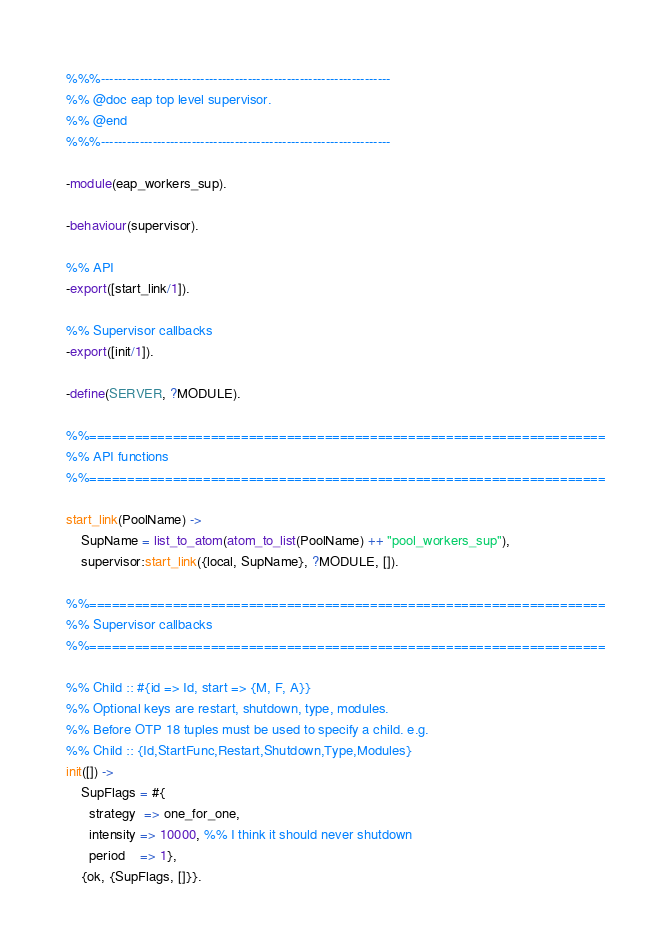Convert code to text. <code><loc_0><loc_0><loc_500><loc_500><_Erlang_>%%%-------------------------------------------------------------------
%% @doc eap top level supervisor.
%% @end
%%%-------------------------------------------------------------------

-module(eap_workers_sup).

-behaviour(supervisor).

%% API
-export([start_link/1]).

%% Supervisor callbacks
-export([init/1]).

-define(SERVER, ?MODULE).

%%====================================================================
%% API functions
%%====================================================================

start_link(PoolName) ->
    SupName = list_to_atom(atom_to_list(PoolName) ++ "pool_workers_sup"),
    supervisor:start_link({local, SupName}, ?MODULE, []).

%%====================================================================
%% Supervisor callbacks
%%====================================================================

%% Child :: #{id => Id, start => {M, F, A}}
%% Optional keys are restart, shutdown, type, modules.
%% Before OTP 18 tuples must be used to specify a child. e.g.
%% Child :: {Id,StartFunc,Restart,Shutdown,Type,Modules}
init([]) ->
    SupFlags = #{
      strategy  => one_for_one,
      intensity => 10000, %% I think it should never shutdown
      period    => 1},
    {ok, {SupFlags, []}}.

</code> 